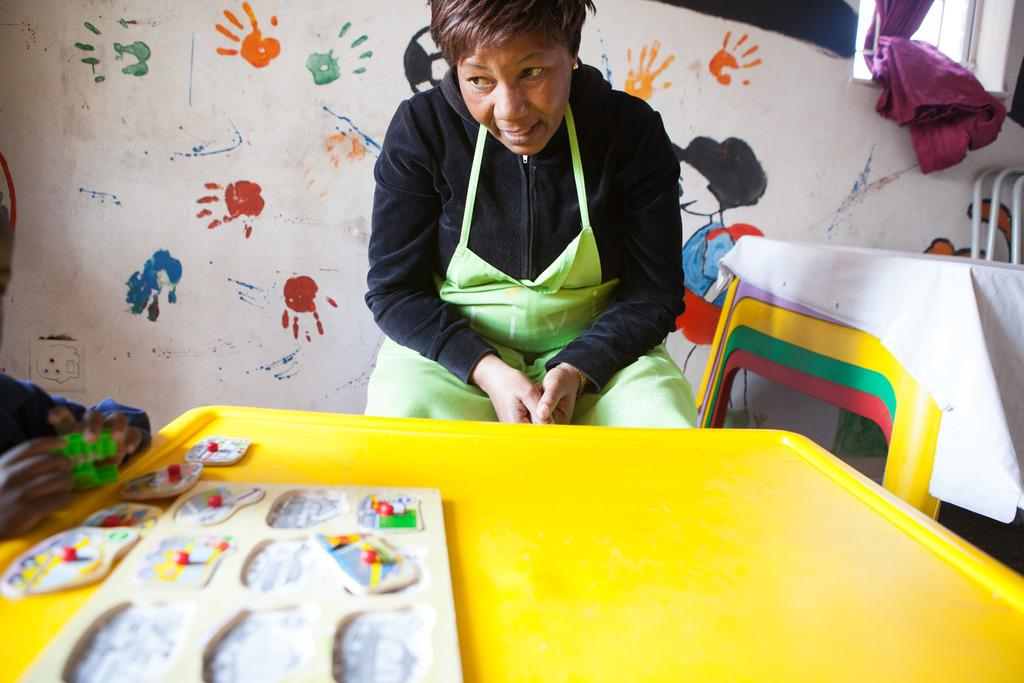Who is present in the image? There is a woman in the image. What is the woman doing in the image? The woman is sitting in front of a table. What can be seen on the table in the image? There are objects placed on the table. What is visible in the background of the image? There is a painted wall and additional tables visible in the background. What type of hook can be seen hanging from the ceiling in the image? There is no hook visible in the image; it only features a woman sitting in front of a table with objects on it and a painted wall in the background. 